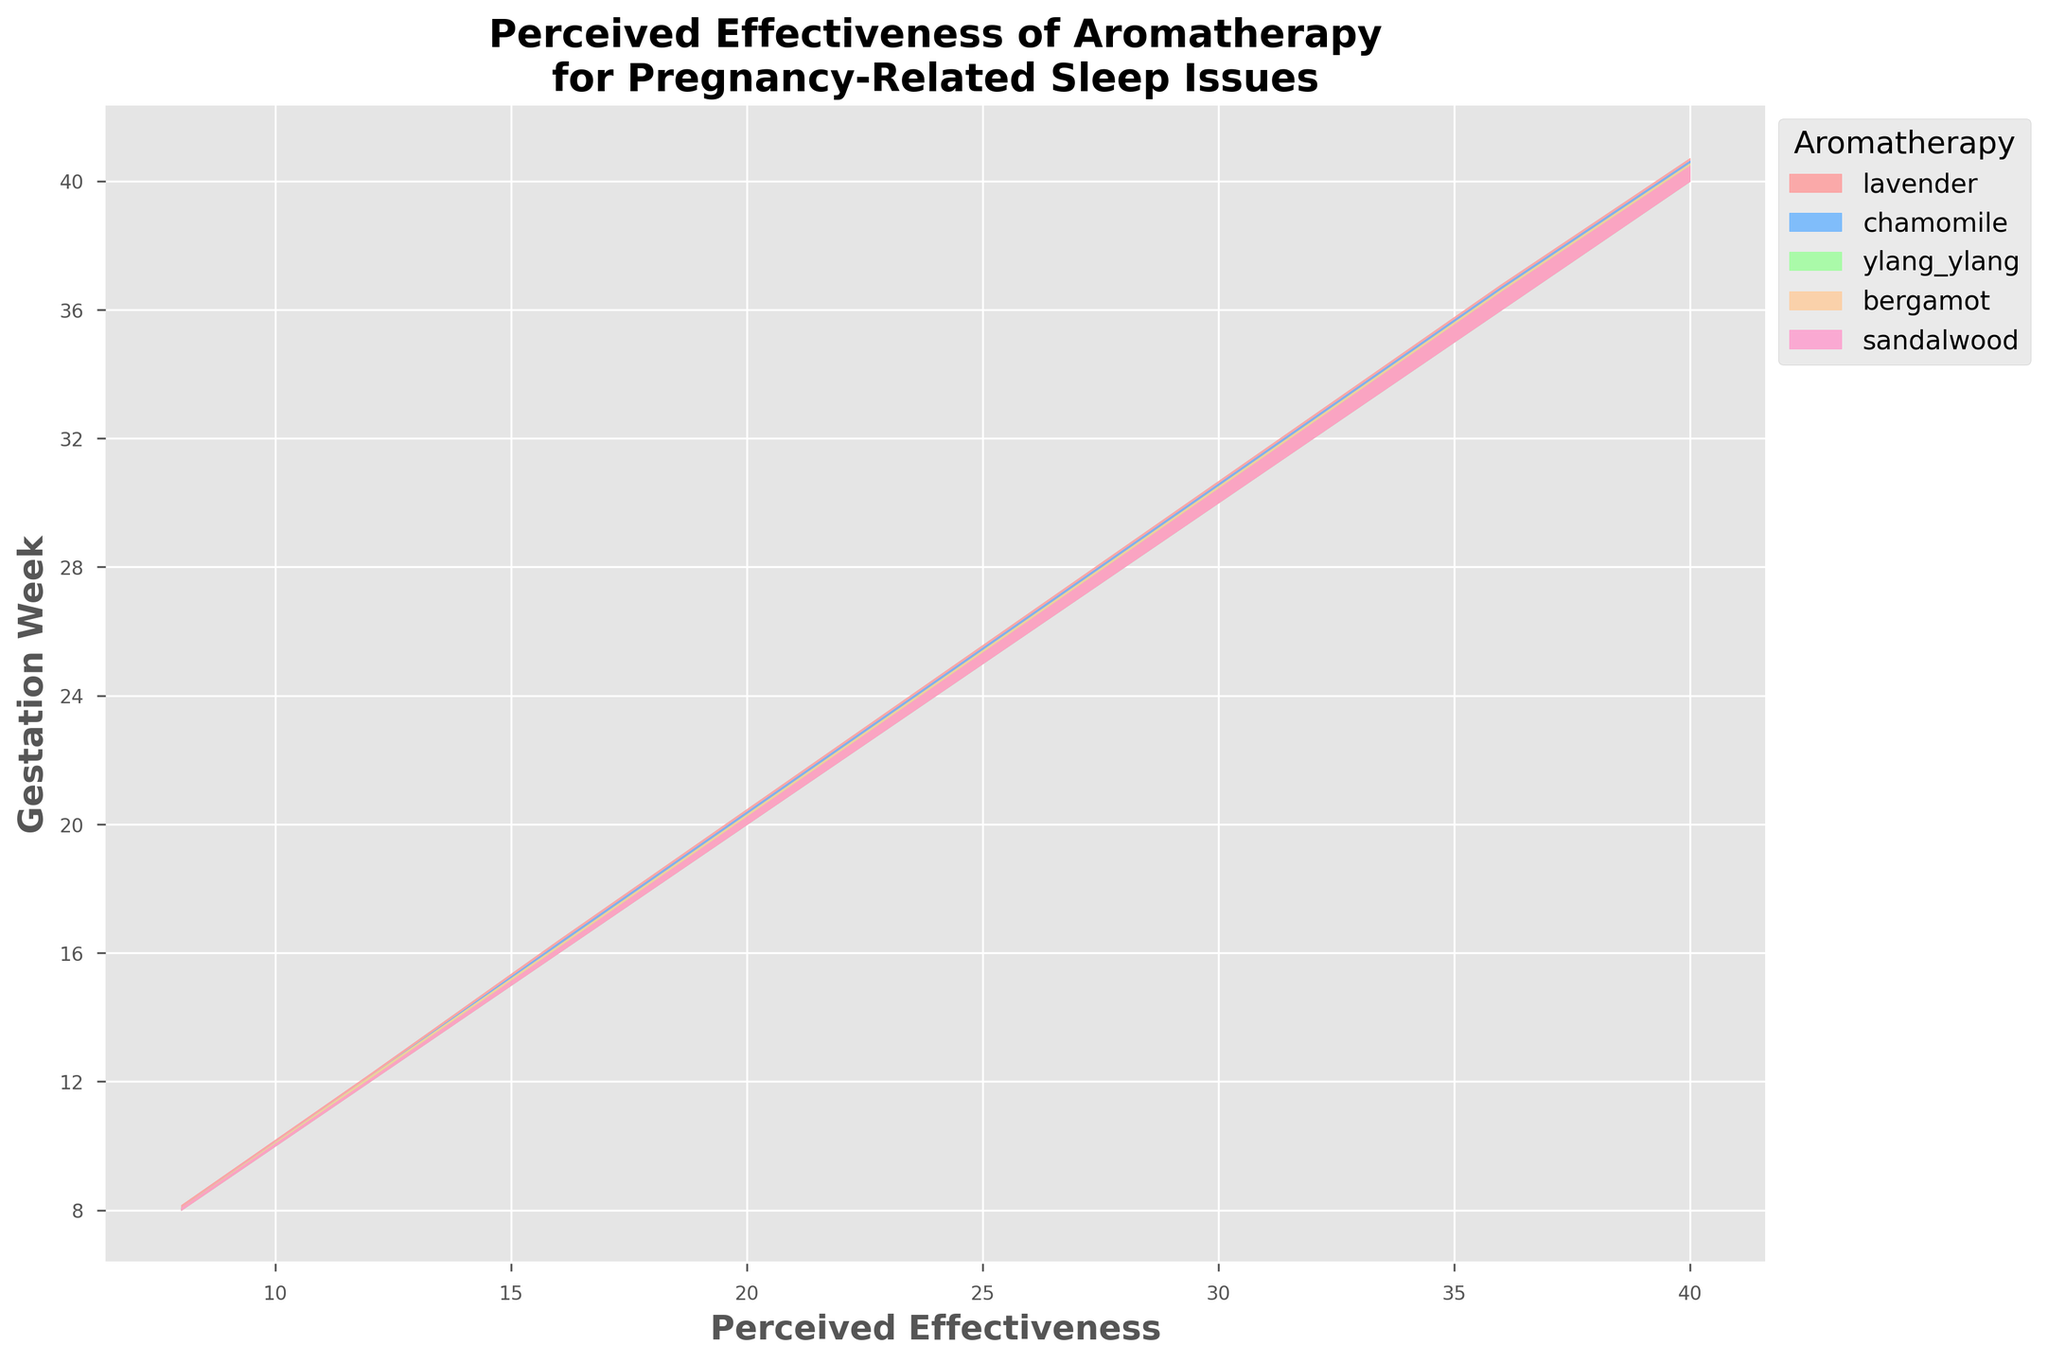What is the title of the figure? The title of the figure is located at the top and clearly states the main focus of the plot.
Answer: Perceived Effectiveness of Aromatherapy for Pregnancy-Related Sleep Issues Which weeks are represented along the y-axis? The y-axis of the plot represents the gestation weeks, each marked with corresponding labels.
Answer: 8, 12, 16, 20, 24, 28, 32, 36, 40 Which aromatherapy has the highest perceived effectiveness at 36 weeks of gestation? At 36 weeks of gestation, the height of each colored area will indicate the perceived effectiveness of each aromatherapy. The highest point corresponds to lavender.
Answer: Lavender How does the perceived effectiveness of chamomile change from week 8 to week 24? To find this, we look at the data points representing chamomile and track its heights from week 8 to week 24. The perceived effectiveness increases steadily over these weeks.
Answer: It increases from 0.1 to 0.6 At which gestational week does bergamot aromatherapy reach its highest perceived effectiveness? The peak of the bergamot area corresponds to the gestational week when it has the highest value. This peak occurs at week 36.
Answer: 36 weeks Is the perceived effectiveness of sandalwood higher at week 32 or week 40? Comparing the heights of the colored areas for sandalwood at week 32 and week 40 will indicate which week has higher effectiveness. Around week 32 it is higher since sandalwood appears higher at that point.
Answer: Week 32 Out of all aromatherapy types, which has the lowest perceived effectiveness at week 20? By looking at the heights of all the aromatherapy types at week 20, the one with the least height is sandalwood.
Answer: Sandalwood What is the average effectiveness of lavender from week 8 to week 40? The perceived effectiveness values for lavender are: 0.2, 0.3, 0.5, 0.6, 0.7, 0.8, 0.9, 1.0, 0.9. Summing these values and dividing by the number of weeks (9) gives the average. 
(0.2 + 0.3 + 0.5 + 0.6 + 0.7 + 0.8 + 0.9 + 1.0 + 0.9) / 9 = 5.9 / 9 ≈ 0.66
Answer: 0.66 Between which weeks does the perceived effectiveness of ylang ylang increase the most? To find the interval with the most substantial increase, we need to compare the differences between consecutive weeks. The steepest increase is between weeks 12 and 16 (0.2 to 0.3 ).
Answer: Week 12 to 16 Which aromatherapy shows consistent growth in perceived effectiveness throughout the entire gestation period? By observing each line, chamomile shows a consistent upward trend without any decline throughout the gestation weeks.
Answer: Chamomile 